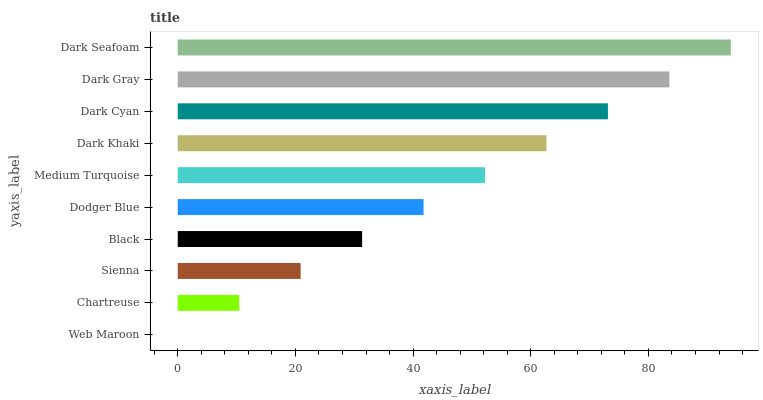Is Web Maroon the minimum?
Answer yes or no. Yes. Is Dark Seafoam the maximum?
Answer yes or no. Yes. Is Chartreuse the minimum?
Answer yes or no. No. Is Chartreuse the maximum?
Answer yes or no. No. Is Chartreuse greater than Web Maroon?
Answer yes or no. Yes. Is Web Maroon less than Chartreuse?
Answer yes or no. Yes. Is Web Maroon greater than Chartreuse?
Answer yes or no. No. Is Chartreuse less than Web Maroon?
Answer yes or no. No. Is Medium Turquoise the high median?
Answer yes or no. Yes. Is Dodger Blue the low median?
Answer yes or no. Yes. Is Chartreuse the high median?
Answer yes or no. No. Is Web Maroon the low median?
Answer yes or no. No. 